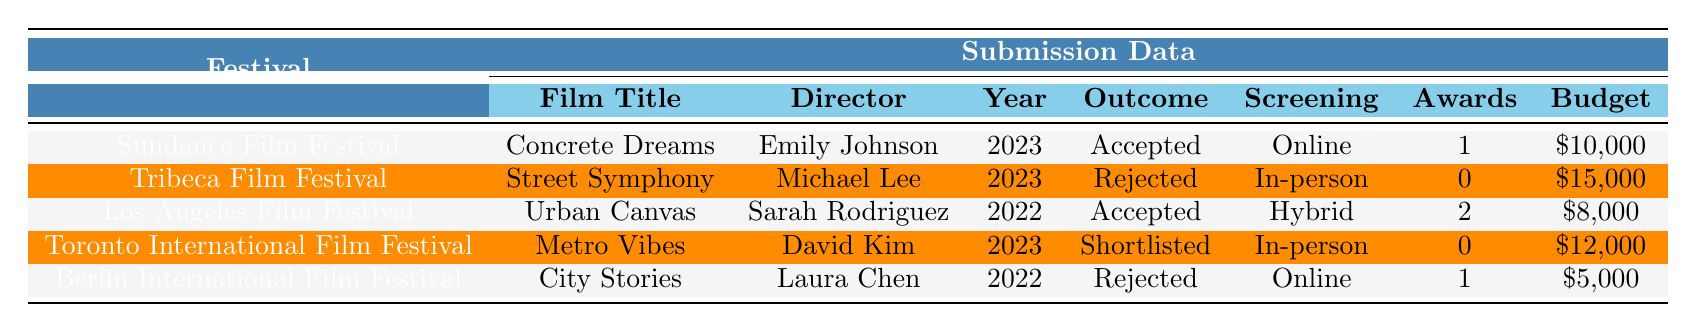What was the outcome of "Metro Vibes" at the Toronto International Film Festival? The outcome listed for "Metro Vibes" is "Shortlisted" in the table under the respective festival's submission data.
Answer: Shortlisted How many awards were won by "Urban Canvas"? The table indicates that "Urban Canvas" won 2 awards in the Submission Data section.
Answer: 2 Which festival accepted the most films in 2023? In 2023, both "Concrete Dreams" and "Street Symphony" were submitted to the Sundance and Tribeca festivals, respectively. However, only "Concrete Dreams" was accepted at Sundance, whereas "Street Symphony" was rejected. Therefore, Sundance accepted the only film in 2023.
Answer: Sundance Film Festival What is the average budget of the films submitted to the festivals? To find the average budget, convert each budget to numbers: 10000, 15000, 8000, 12000, 5000. Their sum is 10000 + 15000 + 8000 + 12000 + 5000 = 60000. Divide by the number of films: 60000/5 = 12000.
Answer: $12,000 Did any film win awards but also get rejected? The table shows that "City Stories" was rejected and won 1 award, indicating that there was a film that won awards and was rejected.
Answer: Yes Which film had the lowest budget and what was its outcome? "City Stories" had the lowest budget of $5,000 and its outcome was "Rejected" according to the Submission Data.
Answer: Rejected What percentage of films were accepted after submission? There are 5 films total, with 3 accepted (Concrete Dreams and Urban Canvas). Therefore, the percentage for acceptance is (3/5) * 100 = 60%.
Answer: 60% Which festival had only one submission in 2022? The only festival with a single submission in 2022 was the Los Angeles Film Festival, which featured "Urban Canvas."
Answer: Los Angeles Film Festival How many films were submitted at each festival? Summarizing, Sundance had 1 (Concrete Dreams), Tribeca 1 (Street Symphony), Los Angeles 1 (Urban Canvas), Toronto 1 (Metro Vibes), and Berlin 1 (City Stories). Each festival had exactly one submission.
Answer: 1 film per festival 